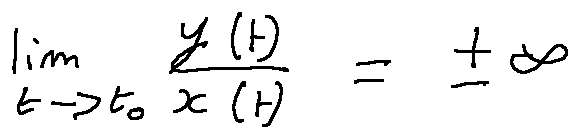Convert formula to latex. <formula><loc_0><loc_0><loc_500><loc_500>\lim \lim i t s _ { t \rightarrow t _ { 0 } } \frac { y ( t ) } { x ( t ) } = \pm \infty</formula> 